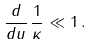Convert formula to latex. <formula><loc_0><loc_0><loc_500><loc_500>\frac { d } { d u } \, \frac { 1 } { \kappa } \ll 1 \, .</formula> 